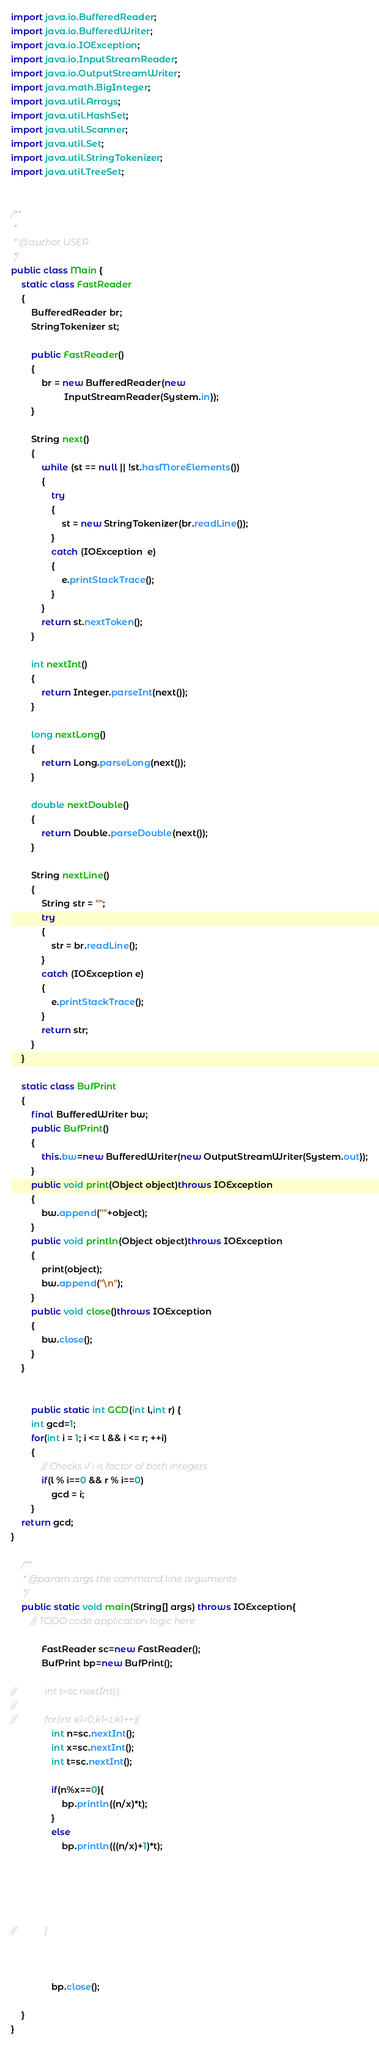<code> <loc_0><loc_0><loc_500><loc_500><_Java_>import java.io.BufferedReader;
import java.io.BufferedWriter;
import java.io.IOException;
import java.io.InputStreamReader;
import java.io.OutputStreamWriter;
import java.math.BigInteger;
import java.util.Arrays;
import java.util.HashSet;
import java.util.Scanner;
import java.util.Set;
import java.util.StringTokenizer;
import java.util.TreeSet;


/**
 *
 * @author USER
 */
public class Main {
    static class FastReader 
    { 
        BufferedReader br; 
        StringTokenizer st; 
  
        public FastReader() 
        { 
            br = new BufferedReader(new
                     InputStreamReader(System.in)); 
        } 
  
        String next() 
        { 
            while (st == null || !st.hasMoreElements()) 
            { 
                try
                { 
                    st = new StringTokenizer(br.readLine()); 
                } 
                catch (IOException  e) 
                { 
                    e.printStackTrace(); 
                } 
            } 
            return st.nextToken(); 
        } 
  
        int nextInt() 
        { 
            return Integer.parseInt(next()); 
        } 
  
        long nextLong() 
        { 
            return Long.parseLong(next()); 
        } 
  
        double nextDouble() 
        { 
            return Double.parseDouble(next()); 
        } 
  
        String nextLine() 
        { 
            String str = ""; 
            try
            { 
                str = br.readLine(); 
            } 
            catch (IOException e) 
            { 
                e.printStackTrace(); 
            } 
            return str; 
        } 
    } 
    
    static class BufPrint
    {
        final BufferedWriter bw;
        public BufPrint()
        {
            this.bw=new BufferedWriter(new OutputStreamWriter(System.out));
        }
        public void print(Object object)throws IOException
        {
            bw.append(""+object);
        }
        public void println(Object object)throws IOException
        {
            print(object);
            bw.append("\n");
        }
        public void close()throws IOException
        {
            bw.close();
        }
    }
    

        public static int GCD(int l,int r) {
        int gcd=1;
        for(int i = 1; i <= l && i <= r; ++i)
        {
            // Checks if i is factor of both integers
            if(l % i==0 && r % i==0)
                gcd = i;
        }
    return gcd;
}
    
    /**
     * @param args the command line arguments
     */
    public static void main(String[] args) throws IOException{
        // TODO code application logic here
        
            FastReader sc=new FastReader(); 
            BufPrint bp=new BufPrint();

//            int t=sc.nextInt();
//            
//            for(int k1=0;k1<t;k1++){
                int n=sc.nextInt();
                int x=sc.nextInt();
                int t=sc.nextInt();
                
                if(n%x==0){
                    bp.println((n/x)*t);
                }
                else
                    bp.println(((n/x)+1)*t);
                
                
                
                
 
//            }
            
           
           
                bp.close();
            
    }
}</code> 